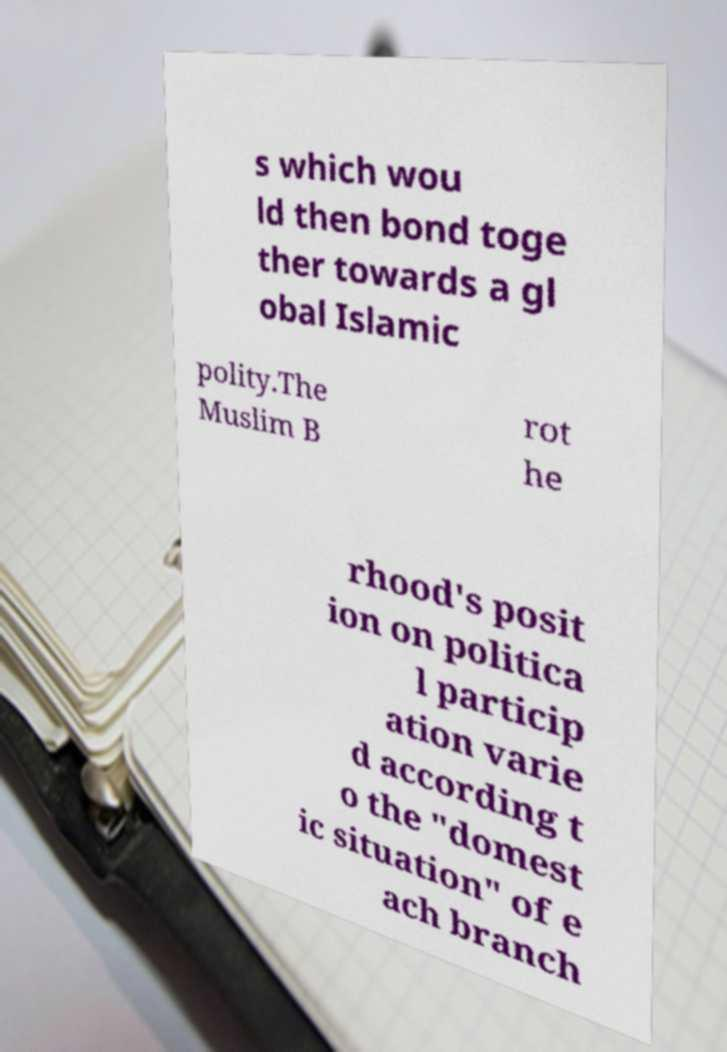I need the written content from this picture converted into text. Can you do that? s which wou ld then bond toge ther towards a gl obal Islamic polity.The Muslim B rot he rhood's posit ion on politica l particip ation varie d according t o the "domest ic situation" of e ach branch 